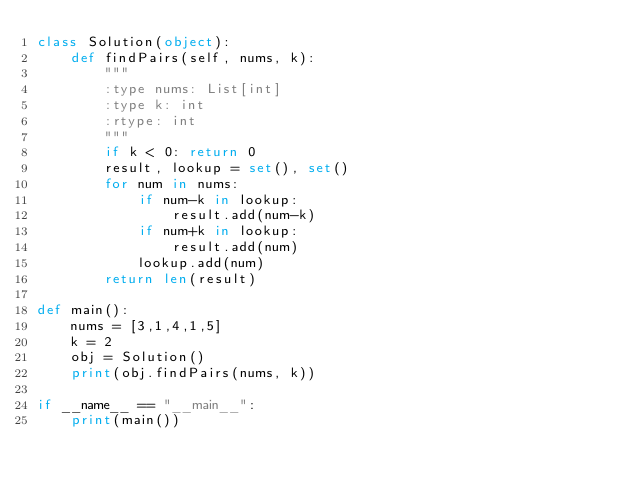<code> <loc_0><loc_0><loc_500><loc_500><_Python_>class Solution(object):
    def findPairs(self, nums, k):
        """
        :type nums: List[int]
        :type k: int
        :rtype: int
        """
        if k < 0: return 0
        result, lookup = set(), set()
        for num in nums:
            if num-k in lookup:
                result.add(num-k)
            if num+k in lookup:
                result.add(num)
            lookup.add(num)
        return len(result)

def main():
    nums = [3,1,4,1,5]
    k = 2
    obj = Solution()
    print(obj.findPairs(nums, k))

if __name__ == "__main__":
    print(main())
</code> 